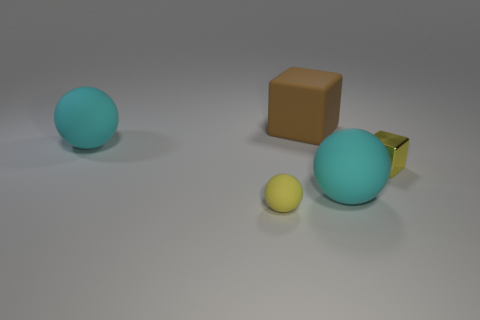Are the sizes of the yellow cube and the brown object proportional to each other? The yellow cube is substantially smaller in size when compared to the brown object, which appears to be a mid-sized geometric shape that dwarfs the small cube. 